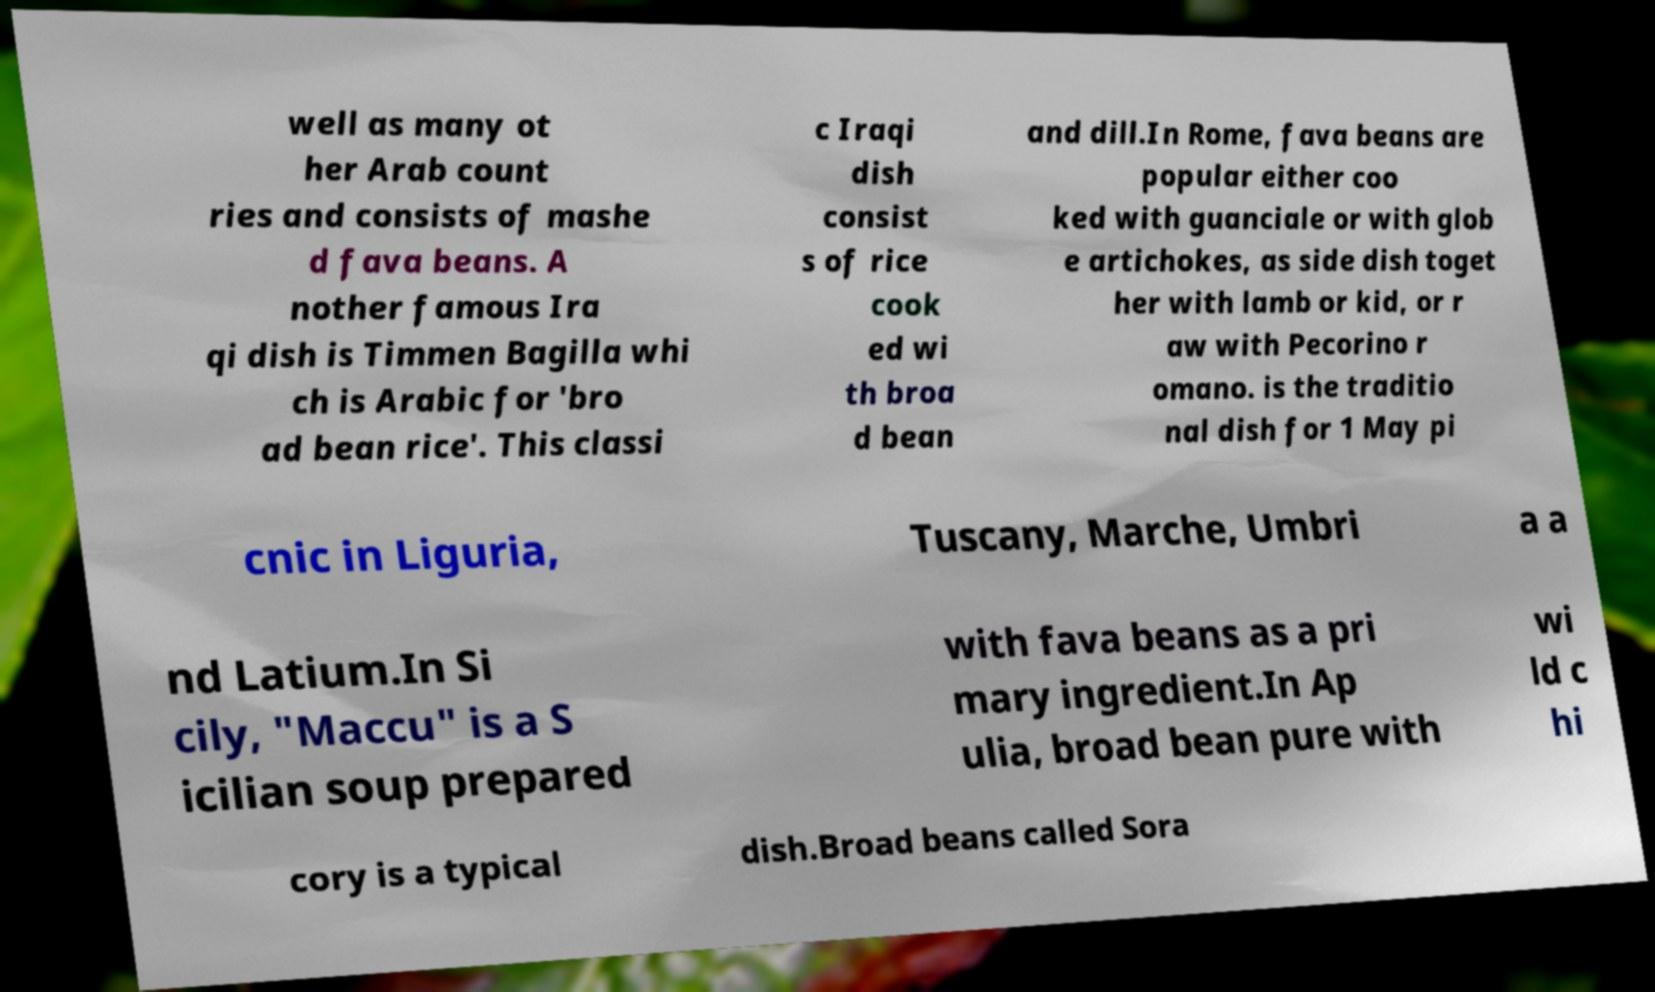Could you extract and type out the text from this image? well as many ot her Arab count ries and consists of mashe d fava beans. A nother famous Ira qi dish is Timmen Bagilla whi ch is Arabic for 'bro ad bean rice'. This classi c Iraqi dish consist s of rice cook ed wi th broa d bean and dill.In Rome, fava beans are popular either coo ked with guanciale or with glob e artichokes, as side dish toget her with lamb or kid, or r aw with Pecorino r omano. is the traditio nal dish for 1 May pi cnic in Liguria, Tuscany, Marche, Umbri a a nd Latium.In Si cily, "Maccu" is a S icilian soup prepared with fava beans as a pri mary ingredient.In Ap ulia, broad bean pure with wi ld c hi cory is a typical dish.Broad beans called Sora 